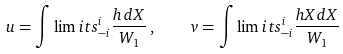Convert formula to latex. <formula><loc_0><loc_0><loc_500><loc_500>u = \int \lim i t s _ { - i } ^ { i } \frac { h \, d X } { W _ { 1 } } \, , \quad v = \int \lim i t s _ { - i } ^ { i } \frac { h X d X } { W _ { 1 } }</formula> 